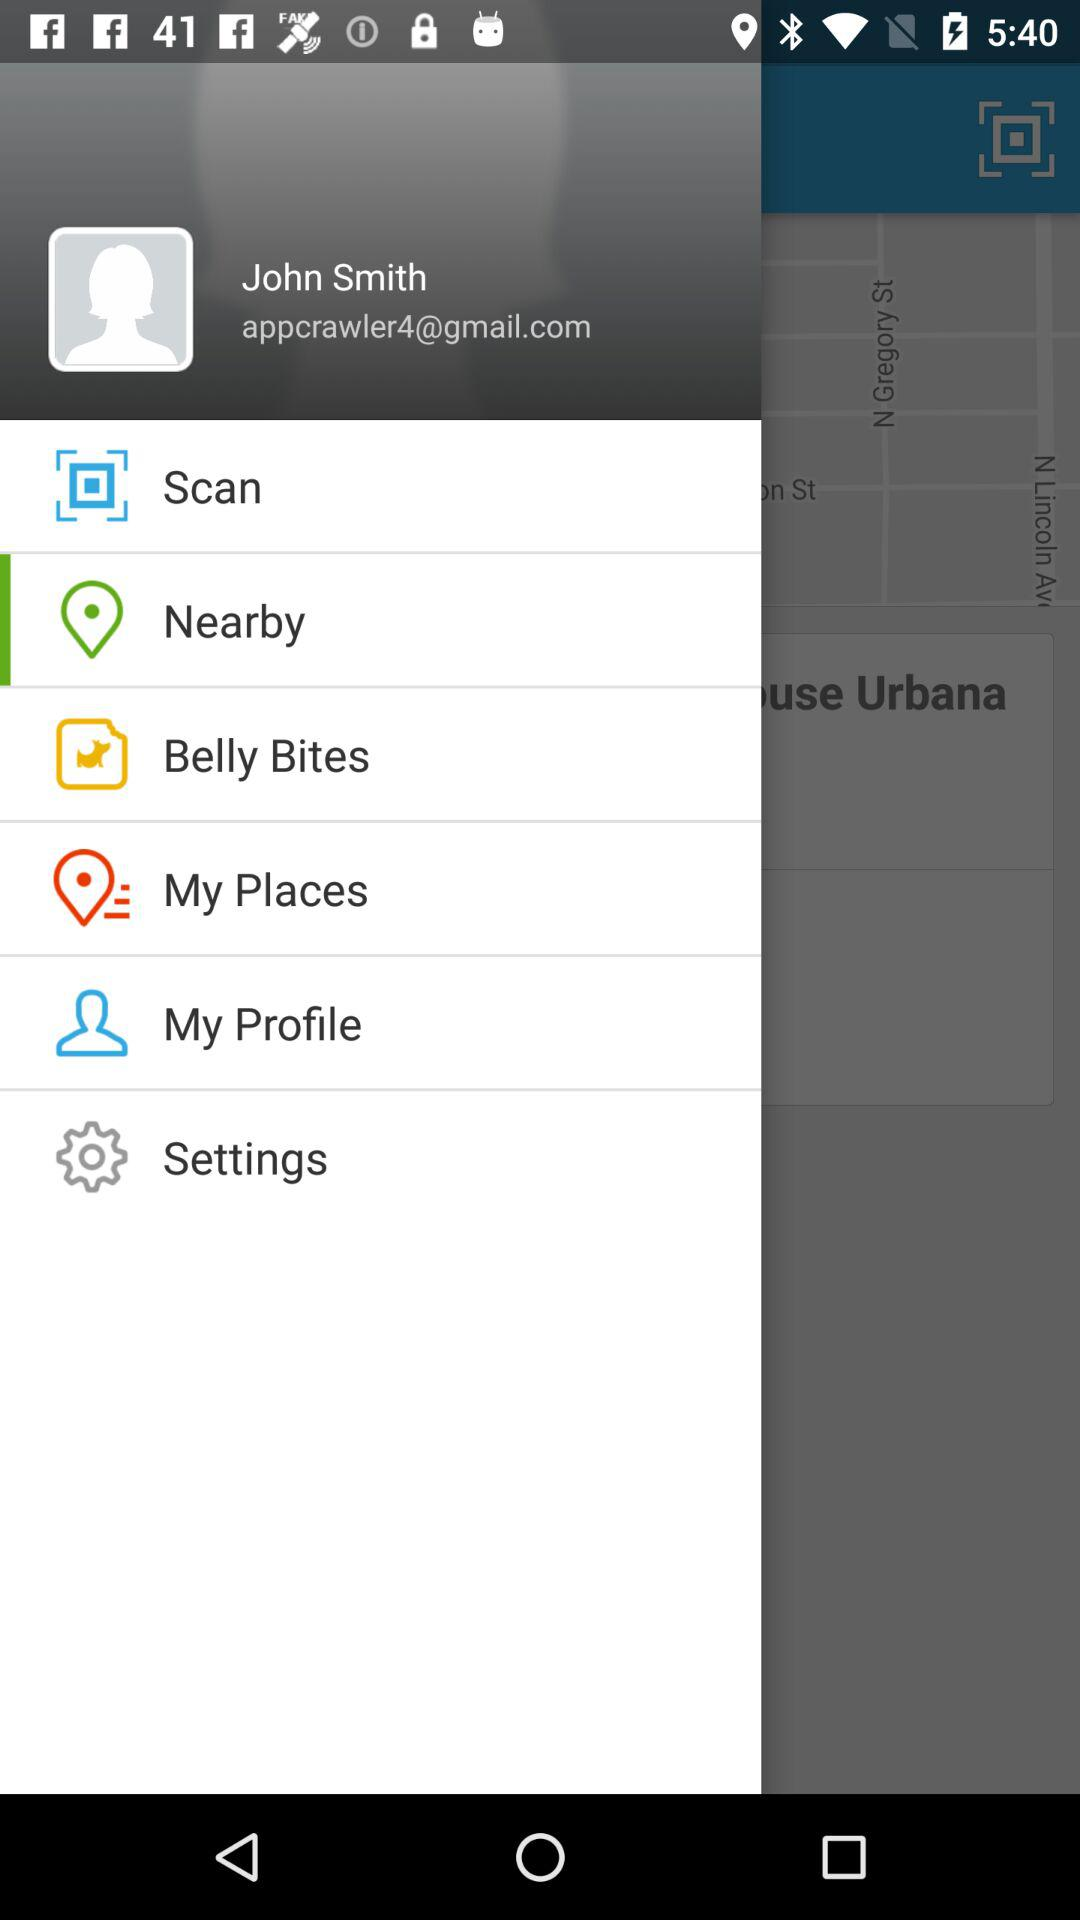What is the user's profile name? The user's profile name is John Smith. 